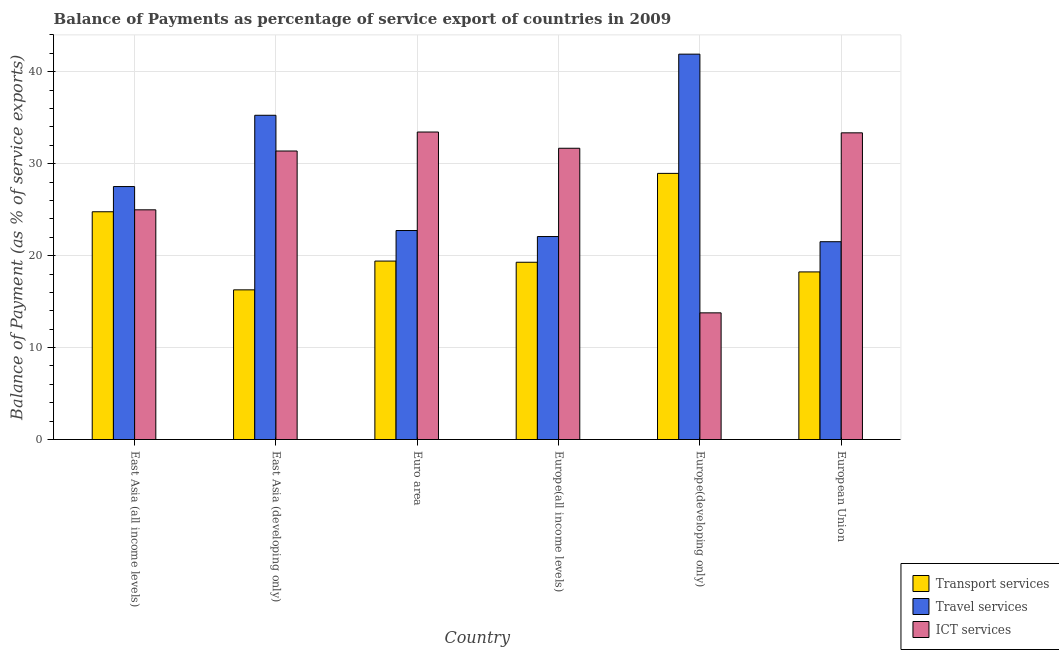How many groups of bars are there?
Make the answer very short. 6. How many bars are there on the 3rd tick from the right?
Provide a short and direct response. 3. What is the label of the 3rd group of bars from the left?
Your answer should be compact. Euro area. In how many cases, is the number of bars for a given country not equal to the number of legend labels?
Make the answer very short. 0. What is the balance of payment of travel services in East Asia (developing only)?
Your answer should be very brief. 35.27. Across all countries, what is the maximum balance of payment of ict services?
Provide a succinct answer. 33.45. Across all countries, what is the minimum balance of payment of travel services?
Make the answer very short. 21.52. In which country was the balance of payment of travel services maximum?
Provide a succinct answer. Europe(developing only). What is the total balance of payment of transport services in the graph?
Offer a terse response. 126.92. What is the difference between the balance of payment of travel services in Europe(all income levels) and that in European Union?
Your answer should be compact. 0.56. What is the difference between the balance of payment of travel services in European Union and the balance of payment of ict services in Europe(all income levels)?
Your response must be concise. -10.16. What is the average balance of payment of travel services per country?
Provide a succinct answer. 28.5. What is the difference between the balance of payment of travel services and balance of payment of transport services in East Asia (all income levels)?
Ensure brevity in your answer.  2.74. In how many countries, is the balance of payment of transport services greater than 20 %?
Make the answer very short. 2. What is the ratio of the balance of payment of transport services in Europe(all income levels) to that in European Union?
Your answer should be very brief. 1.06. Is the balance of payment of transport services in Euro area less than that in Europe(developing only)?
Your answer should be compact. Yes. What is the difference between the highest and the second highest balance of payment of transport services?
Offer a very short reply. 4.17. What is the difference between the highest and the lowest balance of payment of travel services?
Provide a succinct answer. 20.4. In how many countries, is the balance of payment of ict services greater than the average balance of payment of ict services taken over all countries?
Provide a succinct answer. 4. What does the 3rd bar from the left in Europe(developing only) represents?
Offer a terse response. ICT services. What does the 1st bar from the right in East Asia (developing only) represents?
Offer a very short reply. ICT services. How many bars are there?
Your answer should be compact. 18. Are all the bars in the graph horizontal?
Your answer should be very brief. No. How many countries are there in the graph?
Ensure brevity in your answer.  6. What is the difference between two consecutive major ticks on the Y-axis?
Give a very brief answer. 10. Does the graph contain any zero values?
Your answer should be compact. No. What is the title of the graph?
Ensure brevity in your answer.  Balance of Payments as percentage of service export of countries in 2009. Does "Ages 20-60" appear as one of the legend labels in the graph?
Your answer should be compact. No. What is the label or title of the Y-axis?
Keep it short and to the point. Balance of Payment (as % of service exports). What is the Balance of Payment (as % of service exports) of Transport services in East Asia (all income levels)?
Your answer should be very brief. 24.77. What is the Balance of Payment (as % of service exports) in Travel services in East Asia (all income levels)?
Ensure brevity in your answer.  27.51. What is the Balance of Payment (as % of service exports) of ICT services in East Asia (all income levels)?
Provide a short and direct response. 24.98. What is the Balance of Payment (as % of service exports) in Transport services in East Asia (developing only)?
Ensure brevity in your answer.  16.28. What is the Balance of Payment (as % of service exports) in Travel services in East Asia (developing only)?
Ensure brevity in your answer.  35.27. What is the Balance of Payment (as % of service exports) of ICT services in East Asia (developing only)?
Make the answer very short. 31.38. What is the Balance of Payment (as % of service exports) in Transport services in Euro area?
Ensure brevity in your answer.  19.41. What is the Balance of Payment (as % of service exports) of Travel services in Euro area?
Your response must be concise. 22.73. What is the Balance of Payment (as % of service exports) in ICT services in Euro area?
Make the answer very short. 33.45. What is the Balance of Payment (as % of service exports) in Transport services in Europe(all income levels)?
Offer a very short reply. 19.28. What is the Balance of Payment (as % of service exports) of Travel services in Europe(all income levels)?
Your answer should be very brief. 22.08. What is the Balance of Payment (as % of service exports) of ICT services in Europe(all income levels)?
Keep it short and to the point. 31.68. What is the Balance of Payment (as % of service exports) of Transport services in Europe(developing only)?
Offer a very short reply. 28.95. What is the Balance of Payment (as % of service exports) in Travel services in Europe(developing only)?
Ensure brevity in your answer.  41.92. What is the Balance of Payment (as % of service exports) of ICT services in Europe(developing only)?
Give a very brief answer. 13.78. What is the Balance of Payment (as % of service exports) of Transport services in European Union?
Your answer should be compact. 18.23. What is the Balance of Payment (as % of service exports) in Travel services in European Union?
Ensure brevity in your answer.  21.52. What is the Balance of Payment (as % of service exports) in ICT services in European Union?
Keep it short and to the point. 33.36. Across all countries, what is the maximum Balance of Payment (as % of service exports) of Transport services?
Give a very brief answer. 28.95. Across all countries, what is the maximum Balance of Payment (as % of service exports) of Travel services?
Your answer should be compact. 41.92. Across all countries, what is the maximum Balance of Payment (as % of service exports) in ICT services?
Make the answer very short. 33.45. Across all countries, what is the minimum Balance of Payment (as % of service exports) in Transport services?
Give a very brief answer. 16.28. Across all countries, what is the minimum Balance of Payment (as % of service exports) in Travel services?
Give a very brief answer. 21.52. Across all countries, what is the minimum Balance of Payment (as % of service exports) in ICT services?
Make the answer very short. 13.78. What is the total Balance of Payment (as % of service exports) in Transport services in the graph?
Your response must be concise. 126.92. What is the total Balance of Payment (as % of service exports) of Travel services in the graph?
Provide a short and direct response. 171.03. What is the total Balance of Payment (as % of service exports) of ICT services in the graph?
Make the answer very short. 168.63. What is the difference between the Balance of Payment (as % of service exports) of Transport services in East Asia (all income levels) and that in East Asia (developing only)?
Give a very brief answer. 8.49. What is the difference between the Balance of Payment (as % of service exports) of Travel services in East Asia (all income levels) and that in East Asia (developing only)?
Your response must be concise. -7.75. What is the difference between the Balance of Payment (as % of service exports) in ICT services in East Asia (all income levels) and that in East Asia (developing only)?
Offer a very short reply. -6.4. What is the difference between the Balance of Payment (as % of service exports) of Transport services in East Asia (all income levels) and that in Euro area?
Provide a short and direct response. 5.36. What is the difference between the Balance of Payment (as % of service exports) in Travel services in East Asia (all income levels) and that in Euro area?
Offer a terse response. 4.78. What is the difference between the Balance of Payment (as % of service exports) in ICT services in East Asia (all income levels) and that in Euro area?
Provide a short and direct response. -8.46. What is the difference between the Balance of Payment (as % of service exports) in Transport services in East Asia (all income levels) and that in Europe(all income levels)?
Give a very brief answer. 5.49. What is the difference between the Balance of Payment (as % of service exports) of Travel services in East Asia (all income levels) and that in Europe(all income levels)?
Make the answer very short. 5.44. What is the difference between the Balance of Payment (as % of service exports) in ICT services in East Asia (all income levels) and that in Europe(all income levels)?
Offer a terse response. -6.7. What is the difference between the Balance of Payment (as % of service exports) of Transport services in East Asia (all income levels) and that in Europe(developing only)?
Your answer should be compact. -4.17. What is the difference between the Balance of Payment (as % of service exports) in Travel services in East Asia (all income levels) and that in Europe(developing only)?
Your answer should be compact. -14.4. What is the difference between the Balance of Payment (as % of service exports) of ICT services in East Asia (all income levels) and that in Europe(developing only)?
Ensure brevity in your answer.  11.21. What is the difference between the Balance of Payment (as % of service exports) in Transport services in East Asia (all income levels) and that in European Union?
Offer a terse response. 6.54. What is the difference between the Balance of Payment (as % of service exports) of Travel services in East Asia (all income levels) and that in European Union?
Your response must be concise. 6. What is the difference between the Balance of Payment (as % of service exports) of ICT services in East Asia (all income levels) and that in European Union?
Provide a short and direct response. -8.37. What is the difference between the Balance of Payment (as % of service exports) in Transport services in East Asia (developing only) and that in Euro area?
Give a very brief answer. -3.13. What is the difference between the Balance of Payment (as % of service exports) in Travel services in East Asia (developing only) and that in Euro area?
Offer a very short reply. 12.54. What is the difference between the Balance of Payment (as % of service exports) in ICT services in East Asia (developing only) and that in Euro area?
Your response must be concise. -2.07. What is the difference between the Balance of Payment (as % of service exports) of Transport services in East Asia (developing only) and that in Europe(all income levels)?
Make the answer very short. -3. What is the difference between the Balance of Payment (as % of service exports) of Travel services in East Asia (developing only) and that in Europe(all income levels)?
Your response must be concise. 13.19. What is the difference between the Balance of Payment (as % of service exports) in ICT services in East Asia (developing only) and that in Europe(all income levels)?
Keep it short and to the point. -0.3. What is the difference between the Balance of Payment (as % of service exports) in Transport services in East Asia (developing only) and that in Europe(developing only)?
Ensure brevity in your answer.  -12.67. What is the difference between the Balance of Payment (as % of service exports) of Travel services in East Asia (developing only) and that in Europe(developing only)?
Provide a succinct answer. -6.65. What is the difference between the Balance of Payment (as % of service exports) of ICT services in East Asia (developing only) and that in Europe(developing only)?
Ensure brevity in your answer.  17.6. What is the difference between the Balance of Payment (as % of service exports) in Transport services in East Asia (developing only) and that in European Union?
Provide a succinct answer. -1.95. What is the difference between the Balance of Payment (as % of service exports) in Travel services in East Asia (developing only) and that in European Union?
Make the answer very short. 13.75. What is the difference between the Balance of Payment (as % of service exports) of ICT services in East Asia (developing only) and that in European Union?
Your answer should be very brief. -1.98. What is the difference between the Balance of Payment (as % of service exports) of Transport services in Euro area and that in Europe(all income levels)?
Your answer should be very brief. 0.13. What is the difference between the Balance of Payment (as % of service exports) in Travel services in Euro area and that in Europe(all income levels)?
Keep it short and to the point. 0.65. What is the difference between the Balance of Payment (as % of service exports) of ICT services in Euro area and that in Europe(all income levels)?
Provide a short and direct response. 1.77. What is the difference between the Balance of Payment (as % of service exports) in Transport services in Euro area and that in Europe(developing only)?
Ensure brevity in your answer.  -9.54. What is the difference between the Balance of Payment (as % of service exports) in Travel services in Euro area and that in Europe(developing only)?
Your response must be concise. -19.18. What is the difference between the Balance of Payment (as % of service exports) of ICT services in Euro area and that in Europe(developing only)?
Make the answer very short. 19.67. What is the difference between the Balance of Payment (as % of service exports) in Transport services in Euro area and that in European Union?
Keep it short and to the point. 1.18. What is the difference between the Balance of Payment (as % of service exports) of Travel services in Euro area and that in European Union?
Give a very brief answer. 1.22. What is the difference between the Balance of Payment (as % of service exports) of ICT services in Euro area and that in European Union?
Your answer should be very brief. 0.09. What is the difference between the Balance of Payment (as % of service exports) of Transport services in Europe(all income levels) and that in Europe(developing only)?
Offer a terse response. -9.67. What is the difference between the Balance of Payment (as % of service exports) in Travel services in Europe(all income levels) and that in Europe(developing only)?
Your answer should be compact. -19.84. What is the difference between the Balance of Payment (as % of service exports) of ICT services in Europe(all income levels) and that in Europe(developing only)?
Your answer should be very brief. 17.9. What is the difference between the Balance of Payment (as % of service exports) of Transport services in Europe(all income levels) and that in European Union?
Provide a short and direct response. 1.05. What is the difference between the Balance of Payment (as % of service exports) of Travel services in Europe(all income levels) and that in European Union?
Make the answer very short. 0.56. What is the difference between the Balance of Payment (as % of service exports) of ICT services in Europe(all income levels) and that in European Union?
Offer a terse response. -1.68. What is the difference between the Balance of Payment (as % of service exports) of Transport services in Europe(developing only) and that in European Union?
Keep it short and to the point. 10.72. What is the difference between the Balance of Payment (as % of service exports) in Travel services in Europe(developing only) and that in European Union?
Keep it short and to the point. 20.4. What is the difference between the Balance of Payment (as % of service exports) of ICT services in Europe(developing only) and that in European Union?
Give a very brief answer. -19.58. What is the difference between the Balance of Payment (as % of service exports) in Transport services in East Asia (all income levels) and the Balance of Payment (as % of service exports) in Travel services in East Asia (developing only)?
Ensure brevity in your answer.  -10.49. What is the difference between the Balance of Payment (as % of service exports) of Transport services in East Asia (all income levels) and the Balance of Payment (as % of service exports) of ICT services in East Asia (developing only)?
Your answer should be very brief. -6.61. What is the difference between the Balance of Payment (as % of service exports) in Travel services in East Asia (all income levels) and the Balance of Payment (as % of service exports) in ICT services in East Asia (developing only)?
Provide a short and direct response. -3.87. What is the difference between the Balance of Payment (as % of service exports) of Transport services in East Asia (all income levels) and the Balance of Payment (as % of service exports) of Travel services in Euro area?
Provide a short and direct response. 2.04. What is the difference between the Balance of Payment (as % of service exports) in Transport services in East Asia (all income levels) and the Balance of Payment (as % of service exports) in ICT services in Euro area?
Provide a short and direct response. -8.67. What is the difference between the Balance of Payment (as % of service exports) in Travel services in East Asia (all income levels) and the Balance of Payment (as % of service exports) in ICT services in Euro area?
Your answer should be compact. -5.93. What is the difference between the Balance of Payment (as % of service exports) in Transport services in East Asia (all income levels) and the Balance of Payment (as % of service exports) in Travel services in Europe(all income levels)?
Give a very brief answer. 2.69. What is the difference between the Balance of Payment (as % of service exports) of Transport services in East Asia (all income levels) and the Balance of Payment (as % of service exports) of ICT services in Europe(all income levels)?
Ensure brevity in your answer.  -6.91. What is the difference between the Balance of Payment (as % of service exports) in Travel services in East Asia (all income levels) and the Balance of Payment (as % of service exports) in ICT services in Europe(all income levels)?
Make the answer very short. -4.17. What is the difference between the Balance of Payment (as % of service exports) in Transport services in East Asia (all income levels) and the Balance of Payment (as % of service exports) in Travel services in Europe(developing only)?
Give a very brief answer. -17.14. What is the difference between the Balance of Payment (as % of service exports) of Transport services in East Asia (all income levels) and the Balance of Payment (as % of service exports) of ICT services in Europe(developing only)?
Offer a very short reply. 11. What is the difference between the Balance of Payment (as % of service exports) of Travel services in East Asia (all income levels) and the Balance of Payment (as % of service exports) of ICT services in Europe(developing only)?
Your response must be concise. 13.74. What is the difference between the Balance of Payment (as % of service exports) in Transport services in East Asia (all income levels) and the Balance of Payment (as % of service exports) in Travel services in European Union?
Provide a short and direct response. 3.26. What is the difference between the Balance of Payment (as % of service exports) in Transport services in East Asia (all income levels) and the Balance of Payment (as % of service exports) in ICT services in European Union?
Your response must be concise. -8.59. What is the difference between the Balance of Payment (as % of service exports) in Travel services in East Asia (all income levels) and the Balance of Payment (as % of service exports) in ICT services in European Union?
Make the answer very short. -5.84. What is the difference between the Balance of Payment (as % of service exports) in Transport services in East Asia (developing only) and the Balance of Payment (as % of service exports) in Travel services in Euro area?
Your answer should be very brief. -6.45. What is the difference between the Balance of Payment (as % of service exports) in Transport services in East Asia (developing only) and the Balance of Payment (as % of service exports) in ICT services in Euro area?
Offer a terse response. -17.17. What is the difference between the Balance of Payment (as % of service exports) of Travel services in East Asia (developing only) and the Balance of Payment (as % of service exports) of ICT services in Euro area?
Give a very brief answer. 1.82. What is the difference between the Balance of Payment (as % of service exports) of Transport services in East Asia (developing only) and the Balance of Payment (as % of service exports) of Travel services in Europe(all income levels)?
Offer a terse response. -5.8. What is the difference between the Balance of Payment (as % of service exports) in Transport services in East Asia (developing only) and the Balance of Payment (as % of service exports) in ICT services in Europe(all income levels)?
Provide a succinct answer. -15.4. What is the difference between the Balance of Payment (as % of service exports) in Travel services in East Asia (developing only) and the Balance of Payment (as % of service exports) in ICT services in Europe(all income levels)?
Provide a succinct answer. 3.59. What is the difference between the Balance of Payment (as % of service exports) of Transport services in East Asia (developing only) and the Balance of Payment (as % of service exports) of Travel services in Europe(developing only)?
Your answer should be compact. -25.64. What is the difference between the Balance of Payment (as % of service exports) in Transport services in East Asia (developing only) and the Balance of Payment (as % of service exports) in ICT services in Europe(developing only)?
Your answer should be compact. 2.5. What is the difference between the Balance of Payment (as % of service exports) in Travel services in East Asia (developing only) and the Balance of Payment (as % of service exports) in ICT services in Europe(developing only)?
Your answer should be compact. 21.49. What is the difference between the Balance of Payment (as % of service exports) in Transport services in East Asia (developing only) and the Balance of Payment (as % of service exports) in Travel services in European Union?
Offer a very short reply. -5.24. What is the difference between the Balance of Payment (as % of service exports) in Transport services in East Asia (developing only) and the Balance of Payment (as % of service exports) in ICT services in European Union?
Offer a terse response. -17.08. What is the difference between the Balance of Payment (as % of service exports) in Travel services in East Asia (developing only) and the Balance of Payment (as % of service exports) in ICT services in European Union?
Keep it short and to the point. 1.91. What is the difference between the Balance of Payment (as % of service exports) of Transport services in Euro area and the Balance of Payment (as % of service exports) of Travel services in Europe(all income levels)?
Your answer should be very brief. -2.67. What is the difference between the Balance of Payment (as % of service exports) of Transport services in Euro area and the Balance of Payment (as % of service exports) of ICT services in Europe(all income levels)?
Your answer should be very brief. -12.27. What is the difference between the Balance of Payment (as % of service exports) in Travel services in Euro area and the Balance of Payment (as % of service exports) in ICT services in Europe(all income levels)?
Provide a succinct answer. -8.95. What is the difference between the Balance of Payment (as % of service exports) in Transport services in Euro area and the Balance of Payment (as % of service exports) in Travel services in Europe(developing only)?
Provide a short and direct response. -22.51. What is the difference between the Balance of Payment (as % of service exports) in Transport services in Euro area and the Balance of Payment (as % of service exports) in ICT services in Europe(developing only)?
Offer a very short reply. 5.63. What is the difference between the Balance of Payment (as % of service exports) in Travel services in Euro area and the Balance of Payment (as % of service exports) in ICT services in Europe(developing only)?
Offer a very short reply. 8.96. What is the difference between the Balance of Payment (as % of service exports) of Transport services in Euro area and the Balance of Payment (as % of service exports) of Travel services in European Union?
Provide a succinct answer. -2.11. What is the difference between the Balance of Payment (as % of service exports) in Transport services in Euro area and the Balance of Payment (as % of service exports) in ICT services in European Union?
Offer a very short reply. -13.95. What is the difference between the Balance of Payment (as % of service exports) in Travel services in Euro area and the Balance of Payment (as % of service exports) in ICT services in European Union?
Give a very brief answer. -10.63. What is the difference between the Balance of Payment (as % of service exports) of Transport services in Europe(all income levels) and the Balance of Payment (as % of service exports) of Travel services in Europe(developing only)?
Give a very brief answer. -22.64. What is the difference between the Balance of Payment (as % of service exports) of Transport services in Europe(all income levels) and the Balance of Payment (as % of service exports) of ICT services in Europe(developing only)?
Provide a succinct answer. 5.5. What is the difference between the Balance of Payment (as % of service exports) in Travel services in Europe(all income levels) and the Balance of Payment (as % of service exports) in ICT services in Europe(developing only)?
Give a very brief answer. 8.3. What is the difference between the Balance of Payment (as % of service exports) in Transport services in Europe(all income levels) and the Balance of Payment (as % of service exports) in Travel services in European Union?
Provide a succinct answer. -2.24. What is the difference between the Balance of Payment (as % of service exports) in Transport services in Europe(all income levels) and the Balance of Payment (as % of service exports) in ICT services in European Union?
Ensure brevity in your answer.  -14.08. What is the difference between the Balance of Payment (as % of service exports) in Travel services in Europe(all income levels) and the Balance of Payment (as % of service exports) in ICT services in European Union?
Your response must be concise. -11.28. What is the difference between the Balance of Payment (as % of service exports) of Transport services in Europe(developing only) and the Balance of Payment (as % of service exports) of Travel services in European Union?
Give a very brief answer. 7.43. What is the difference between the Balance of Payment (as % of service exports) in Transport services in Europe(developing only) and the Balance of Payment (as % of service exports) in ICT services in European Union?
Make the answer very short. -4.41. What is the difference between the Balance of Payment (as % of service exports) in Travel services in Europe(developing only) and the Balance of Payment (as % of service exports) in ICT services in European Union?
Ensure brevity in your answer.  8.56. What is the average Balance of Payment (as % of service exports) in Transport services per country?
Your answer should be very brief. 21.15. What is the average Balance of Payment (as % of service exports) of Travel services per country?
Your response must be concise. 28.5. What is the average Balance of Payment (as % of service exports) in ICT services per country?
Your answer should be compact. 28.11. What is the difference between the Balance of Payment (as % of service exports) in Transport services and Balance of Payment (as % of service exports) in Travel services in East Asia (all income levels)?
Your response must be concise. -2.74. What is the difference between the Balance of Payment (as % of service exports) in Transport services and Balance of Payment (as % of service exports) in ICT services in East Asia (all income levels)?
Your answer should be compact. -0.21. What is the difference between the Balance of Payment (as % of service exports) of Travel services and Balance of Payment (as % of service exports) of ICT services in East Asia (all income levels)?
Offer a terse response. 2.53. What is the difference between the Balance of Payment (as % of service exports) in Transport services and Balance of Payment (as % of service exports) in Travel services in East Asia (developing only)?
Provide a succinct answer. -18.99. What is the difference between the Balance of Payment (as % of service exports) in Transport services and Balance of Payment (as % of service exports) in ICT services in East Asia (developing only)?
Make the answer very short. -15.1. What is the difference between the Balance of Payment (as % of service exports) in Travel services and Balance of Payment (as % of service exports) in ICT services in East Asia (developing only)?
Offer a terse response. 3.89. What is the difference between the Balance of Payment (as % of service exports) of Transport services and Balance of Payment (as % of service exports) of Travel services in Euro area?
Ensure brevity in your answer.  -3.32. What is the difference between the Balance of Payment (as % of service exports) of Transport services and Balance of Payment (as % of service exports) of ICT services in Euro area?
Offer a very short reply. -14.04. What is the difference between the Balance of Payment (as % of service exports) of Travel services and Balance of Payment (as % of service exports) of ICT services in Euro area?
Offer a very short reply. -10.71. What is the difference between the Balance of Payment (as % of service exports) of Transport services and Balance of Payment (as % of service exports) of Travel services in Europe(all income levels)?
Provide a succinct answer. -2.8. What is the difference between the Balance of Payment (as % of service exports) in Transport services and Balance of Payment (as % of service exports) in ICT services in Europe(all income levels)?
Keep it short and to the point. -12.4. What is the difference between the Balance of Payment (as % of service exports) of Travel services and Balance of Payment (as % of service exports) of ICT services in Europe(all income levels)?
Your response must be concise. -9.6. What is the difference between the Balance of Payment (as % of service exports) of Transport services and Balance of Payment (as % of service exports) of Travel services in Europe(developing only)?
Provide a succinct answer. -12.97. What is the difference between the Balance of Payment (as % of service exports) in Transport services and Balance of Payment (as % of service exports) in ICT services in Europe(developing only)?
Your answer should be very brief. 15.17. What is the difference between the Balance of Payment (as % of service exports) in Travel services and Balance of Payment (as % of service exports) in ICT services in Europe(developing only)?
Your answer should be very brief. 28.14. What is the difference between the Balance of Payment (as % of service exports) in Transport services and Balance of Payment (as % of service exports) in Travel services in European Union?
Ensure brevity in your answer.  -3.28. What is the difference between the Balance of Payment (as % of service exports) in Transport services and Balance of Payment (as % of service exports) in ICT services in European Union?
Your answer should be very brief. -15.13. What is the difference between the Balance of Payment (as % of service exports) of Travel services and Balance of Payment (as % of service exports) of ICT services in European Union?
Ensure brevity in your answer.  -11.84. What is the ratio of the Balance of Payment (as % of service exports) of Transport services in East Asia (all income levels) to that in East Asia (developing only)?
Ensure brevity in your answer.  1.52. What is the ratio of the Balance of Payment (as % of service exports) in Travel services in East Asia (all income levels) to that in East Asia (developing only)?
Give a very brief answer. 0.78. What is the ratio of the Balance of Payment (as % of service exports) in ICT services in East Asia (all income levels) to that in East Asia (developing only)?
Give a very brief answer. 0.8. What is the ratio of the Balance of Payment (as % of service exports) of Transport services in East Asia (all income levels) to that in Euro area?
Your response must be concise. 1.28. What is the ratio of the Balance of Payment (as % of service exports) of Travel services in East Asia (all income levels) to that in Euro area?
Give a very brief answer. 1.21. What is the ratio of the Balance of Payment (as % of service exports) in ICT services in East Asia (all income levels) to that in Euro area?
Your answer should be very brief. 0.75. What is the ratio of the Balance of Payment (as % of service exports) in Transport services in East Asia (all income levels) to that in Europe(all income levels)?
Your answer should be compact. 1.28. What is the ratio of the Balance of Payment (as % of service exports) of Travel services in East Asia (all income levels) to that in Europe(all income levels)?
Make the answer very short. 1.25. What is the ratio of the Balance of Payment (as % of service exports) in ICT services in East Asia (all income levels) to that in Europe(all income levels)?
Offer a terse response. 0.79. What is the ratio of the Balance of Payment (as % of service exports) in Transport services in East Asia (all income levels) to that in Europe(developing only)?
Give a very brief answer. 0.86. What is the ratio of the Balance of Payment (as % of service exports) of Travel services in East Asia (all income levels) to that in Europe(developing only)?
Provide a short and direct response. 0.66. What is the ratio of the Balance of Payment (as % of service exports) in ICT services in East Asia (all income levels) to that in Europe(developing only)?
Ensure brevity in your answer.  1.81. What is the ratio of the Balance of Payment (as % of service exports) in Transport services in East Asia (all income levels) to that in European Union?
Provide a short and direct response. 1.36. What is the ratio of the Balance of Payment (as % of service exports) in Travel services in East Asia (all income levels) to that in European Union?
Give a very brief answer. 1.28. What is the ratio of the Balance of Payment (as % of service exports) in ICT services in East Asia (all income levels) to that in European Union?
Offer a very short reply. 0.75. What is the ratio of the Balance of Payment (as % of service exports) in Transport services in East Asia (developing only) to that in Euro area?
Your response must be concise. 0.84. What is the ratio of the Balance of Payment (as % of service exports) of Travel services in East Asia (developing only) to that in Euro area?
Provide a short and direct response. 1.55. What is the ratio of the Balance of Payment (as % of service exports) in ICT services in East Asia (developing only) to that in Euro area?
Your answer should be compact. 0.94. What is the ratio of the Balance of Payment (as % of service exports) in Transport services in East Asia (developing only) to that in Europe(all income levels)?
Your response must be concise. 0.84. What is the ratio of the Balance of Payment (as % of service exports) of Travel services in East Asia (developing only) to that in Europe(all income levels)?
Provide a succinct answer. 1.6. What is the ratio of the Balance of Payment (as % of service exports) of ICT services in East Asia (developing only) to that in Europe(all income levels)?
Your answer should be very brief. 0.99. What is the ratio of the Balance of Payment (as % of service exports) in Transport services in East Asia (developing only) to that in Europe(developing only)?
Give a very brief answer. 0.56. What is the ratio of the Balance of Payment (as % of service exports) of Travel services in East Asia (developing only) to that in Europe(developing only)?
Your answer should be compact. 0.84. What is the ratio of the Balance of Payment (as % of service exports) of ICT services in East Asia (developing only) to that in Europe(developing only)?
Ensure brevity in your answer.  2.28. What is the ratio of the Balance of Payment (as % of service exports) in Transport services in East Asia (developing only) to that in European Union?
Your answer should be compact. 0.89. What is the ratio of the Balance of Payment (as % of service exports) of Travel services in East Asia (developing only) to that in European Union?
Your response must be concise. 1.64. What is the ratio of the Balance of Payment (as % of service exports) of ICT services in East Asia (developing only) to that in European Union?
Ensure brevity in your answer.  0.94. What is the ratio of the Balance of Payment (as % of service exports) of Travel services in Euro area to that in Europe(all income levels)?
Your response must be concise. 1.03. What is the ratio of the Balance of Payment (as % of service exports) in ICT services in Euro area to that in Europe(all income levels)?
Your response must be concise. 1.06. What is the ratio of the Balance of Payment (as % of service exports) in Transport services in Euro area to that in Europe(developing only)?
Provide a succinct answer. 0.67. What is the ratio of the Balance of Payment (as % of service exports) in Travel services in Euro area to that in Europe(developing only)?
Offer a terse response. 0.54. What is the ratio of the Balance of Payment (as % of service exports) in ICT services in Euro area to that in Europe(developing only)?
Your response must be concise. 2.43. What is the ratio of the Balance of Payment (as % of service exports) in Transport services in Euro area to that in European Union?
Your answer should be very brief. 1.06. What is the ratio of the Balance of Payment (as % of service exports) in Travel services in Euro area to that in European Union?
Keep it short and to the point. 1.06. What is the ratio of the Balance of Payment (as % of service exports) in ICT services in Euro area to that in European Union?
Provide a succinct answer. 1. What is the ratio of the Balance of Payment (as % of service exports) in Transport services in Europe(all income levels) to that in Europe(developing only)?
Keep it short and to the point. 0.67. What is the ratio of the Balance of Payment (as % of service exports) in Travel services in Europe(all income levels) to that in Europe(developing only)?
Keep it short and to the point. 0.53. What is the ratio of the Balance of Payment (as % of service exports) of ICT services in Europe(all income levels) to that in Europe(developing only)?
Provide a short and direct response. 2.3. What is the ratio of the Balance of Payment (as % of service exports) of Transport services in Europe(all income levels) to that in European Union?
Ensure brevity in your answer.  1.06. What is the ratio of the Balance of Payment (as % of service exports) in Travel services in Europe(all income levels) to that in European Union?
Your answer should be very brief. 1.03. What is the ratio of the Balance of Payment (as % of service exports) in ICT services in Europe(all income levels) to that in European Union?
Ensure brevity in your answer.  0.95. What is the ratio of the Balance of Payment (as % of service exports) of Transport services in Europe(developing only) to that in European Union?
Offer a very short reply. 1.59. What is the ratio of the Balance of Payment (as % of service exports) in Travel services in Europe(developing only) to that in European Union?
Give a very brief answer. 1.95. What is the ratio of the Balance of Payment (as % of service exports) in ICT services in Europe(developing only) to that in European Union?
Provide a succinct answer. 0.41. What is the difference between the highest and the second highest Balance of Payment (as % of service exports) in Transport services?
Your response must be concise. 4.17. What is the difference between the highest and the second highest Balance of Payment (as % of service exports) in Travel services?
Give a very brief answer. 6.65. What is the difference between the highest and the second highest Balance of Payment (as % of service exports) in ICT services?
Give a very brief answer. 0.09. What is the difference between the highest and the lowest Balance of Payment (as % of service exports) in Transport services?
Offer a very short reply. 12.67. What is the difference between the highest and the lowest Balance of Payment (as % of service exports) in Travel services?
Make the answer very short. 20.4. What is the difference between the highest and the lowest Balance of Payment (as % of service exports) of ICT services?
Provide a succinct answer. 19.67. 